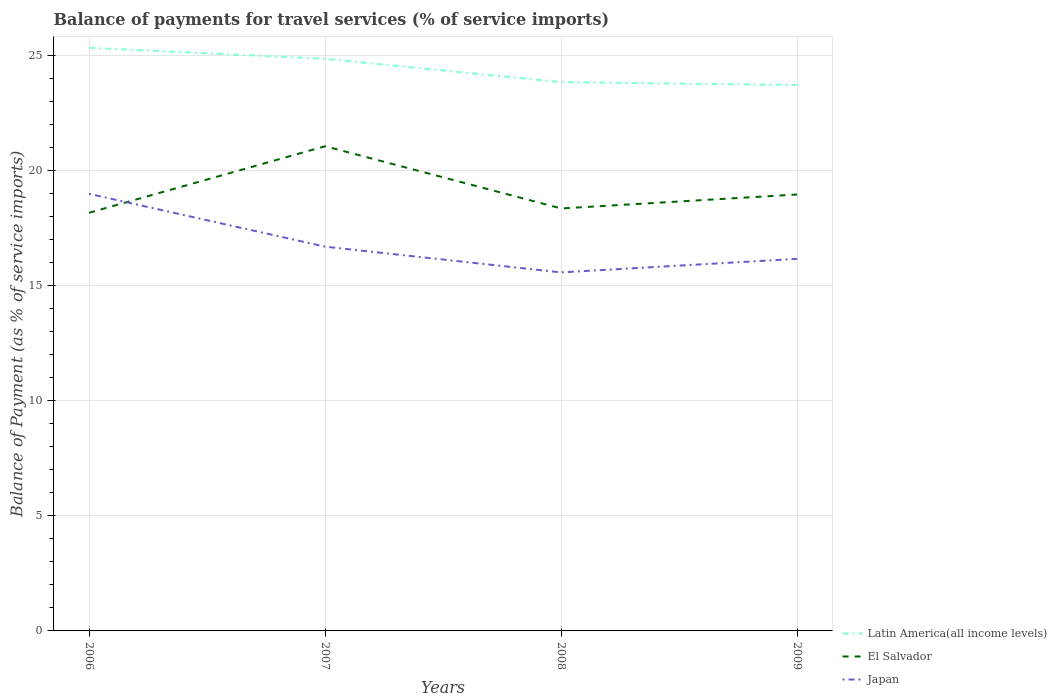How many different coloured lines are there?
Provide a short and direct response. 3. Does the line corresponding to El Salvador intersect with the line corresponding to Latin America(all income levels)?
Your answer should be very brief. No. Across all years, what is the maximum balance of payments for travel services in Japan?
Provide a short and direct response. 15.59. What is the total balance of payments for travel services in Japan in the graph?
Offer a terse response. 1.12. What is the difference between the highest and the second highest balance of payments for travel services in Japan?
Your answer should be very brief. 3.42. Is the balance of payments for travel services in Latin America(all income levels) strictly greater than the balance of payments for travel services in El Salvador over the years?
Give a very brief answer. No. How many lines are there?
Provide a short and direct response. 3. How many years are there in the graph?
Provide a short and direct response. 4. Does the graph contain grids?
Your answer should be compact. Yes. How many legend labels are there?
Your answer should be compact. 3. How are the legend labels stacked?
Give a very brief answer. Vertical. What is the title of the graph?
Your answer should be very brief. Balance of payments for travel services (% of service imports). Does "West Bank and Gaza" appear as one of the legend labels in the graph?
Offer a very short reply. No. What is the label or title of the X-axis?
Offer a very short reply. Years. What is the label or title of the Y-axis?
Offer a very short reply. Balance of Payment (as % of service imports). What is the Balance of Payment (as % of service imports) in Latin America(all income levels) in 2006?
Offer a very short reply. 25.36. What is the Balance of Payment (as % of service imports) in El Salvador in 2006?
Offer a terse response. 18.18. What is the Balance of Payment (as % of service imports) in Japan in 2006?
Your answer should be compact. 19.01. What is the Balance of Payment (as % of service imports) of Latin America(all income levels) in 2007?
Your answer should be very brief. 24.88. What is the Balance of Payment (as % of service imports) of El Salvador in 2007?
Offer a very short reply. 21.08. What is the Balance of Payment (as % of service imports) in Japan in 2007?
Your answer should be very brief. 16.71. What is the Balance of Payment (as % of service imports) in Latin America(all income levels) in 2008?
Offer a terse response. 23.86. What is the Balance of Payment (as % of service imports) of El Salvador in 2008?
Your answer should be compact. 18.37. What is the Balance of Payment (as % of service imports) in Japan in 2008?
Give a very brief answer. 15.59. What is the Balance of Payment (as % of service imports) of Latin America(all income levels) in 2009?
Give a very brief answer. 23.74. What is the Balance of Payment (as % of service imports) of El Salvador in 2009?
Keep it short and to the point. 18.98. What is the Balance of Payment (as % of service imports) of Japan in 2009?
Your response must be concise. 16.18. Across all years, what is the maximum Balance of Payment (as % of service imports) of Latin America(all income levels)?
Offer a terse response. 25.36. Across all years, what is the maximum Balance of Payment (as % of service imports) of El Salvador?
Your answer should be very brief. 21.08. Across all years, what is the maximum Balance of Payment (as % of service imports) in Japan?
Offer a very short reply. 19.01. Across all years, what is the minimum Balance of Payment (as % of service imports) in Latin America(all income levels)?
Your answer should be very brief. 23.74. Across all years, what is the minimum Balance of Payment (as % of service imports) in El Salvador?
Your answer should be very brief. 18.18. Across all years, what is the minimum Balance of Payment (as % of service imports) of Japan?
Give a very brief answer. 15.59. What is the total Balance of Payment (as % of service imports) in Latin America(all income levels) in the graph?
Ensure brevity in your answer.  97.83. What is the total Balance of Payment (as % of service imports) of El Salvador in the graph?
Offer a very short reply. 76.61. What is the total Balance of Payment (as % of service imports) in Japan in the graph?
Give a very brief answer. 67.48. What is the difference between the Balance of Payment (as % of service imports) of Latin America(all income levels) in 2006 and that in 2007?
Offer a very short reply. 0.48. What is the difference between the Balance of Payment (as % of service imports) in El Salvador in 2006 and that in 2007?
Your answer should be compact. -2.89. What is the difference between the Balance of Payment (as % of service imports) of Japan in 2006 and that in 2007?
Make the answer very short. 2.3. What is the difference between the Balance of Payment (as % of service imports) in Latin America(all income levels) in 2006 and that in 2008?
Ensure brevity in your answer.  1.49. What is the difference between the Balance of Payment (as % of service imports) in El Salvador in 2006 and that in 2008?
Your answer should be compact. -0.19. What is the difference between the Balance of Payment (as % of service imports) in Japan in 2006 and that in 2008?
Provide a short and direct response. 3.42. What is the difference between the Balance of Payment (as % of service imports) in Latin America(all income levels) in 2006 and that in 2009?
Give a very brief answer. 1.62. What is the difference between the Balance of Payment (as % of service imports) of El Salvador in 2006 and that in 2009?
Provide a short and direct response. -0.79. What is the difference between the Balance of Payment (as % of service imports) in Japan in 2006 and that in 2009?
Make the answer very short. 2.83. What is the difference between the Balance of Payment (as % of service imports) in Latin America(all income levels) in 2007 and that in 2008?
Your answer should be very brief. 1.02. What is the difference between the Balance of Payment (as % of service imports) in El Salvador in 2007 and that in 2008?
Keep it short and to the point. 2.71. What is the difference between the Balance of Payment (as % of service imports) of Japan in 2007 and that in 2008?
Your response must be concise. 1.12. What is the difference between the Balance of Payment (as % of service imports) in Latin America(all income levels) in 2007 and that in 2009?
Your response must be concise. 1.14. What is the difference between the Balance of Payment (as % of service imports) in El Salvador in 2007 and that in 2009?
Offer a very short reply. 2.1. What is the difference between the Balance of Payment (as % of service imports) of Japan in 2007 and that in 2009?
Give a very brief answer. 0.53. What is the difference between the Balance of Payment (as % of service imports) in Latin America(all income levels) in 2008 and that in 2009?
Your answer should be compact. 0.13. What is the difference between the Balance of Payment (as % of service imports) in El Salvador in 2008 and that in 2009?
Make the answer very short. -0.61. What is the difference between the Balance of Payment (as % of service imports) of Japan in 2008 and that in 2009?
Your answer should be compact. -0.59. What is the difference between the Balance of Payment (as % of service imports) in Latin America(all income levels) in 2006 and the Balance of Payment (as % of service imports) in El Salvador in 2007?
Offer a terse response. 4.28. What is the difference between the Balance of Payment (as % of service imports) in Latin America(all income levels) in 2006 and the Balance of Payment (as % of service imports) in Japan in 2007?
Offer a very short reply. 8.65. What is the difference between the Balance of Payment (as % of service imports) in El Salvador in 2006 and the Balance of Payment (as % of service imports) in Japan in 2007?
Provide a succinct answer. 1.48. What is the difference between the Balance of Payment (as % of service imports) in Latin America(all income levels) in 2006 and the Balance of Payment (as % of service imports) in El Salvador in 2008?
Provide a short and direct response. 6.99. What is the difference between the Balance of Payment (as % of service imports) of Latin America(all income levels) in 2006 and the Balance of Payment (as % of service imports) of Japan in 2008?
Offer a very short reply. 9.77. What is the difference between the Balance of Payment (as % of service imports) in El Salvador in 2006 and the Balance of Payment (as % of service imports) in Japan in 2008?
Your answer should be very brief. 2.59. What is the difference between the Balance of Payment (as % of service imports) of Latin America(all income levels) in 2006 and the Balance of Payment (as % of service imports) of El Salvador in 2009?
Your response must be concise. 6.38. What is the difference between the Balance of Payment (as % of service imports) of Latin America(all income levels) in 2006 and the Balance of Payment (as % of service imports) of Japan in 2009?
Make the answer very short. 9.18. What is the difference between the Balance of Payment (as % of service imports) in El Salvador in 2006 and the Balance of Payment (as % of service imports) in Japan in 2009?
Offer a terse response. 2. What is the difference between the Balance of Payment (as % of service imports) of Latin America(all income levels) in 2007 and the Balance of Payment (as % of service imports) of El Salvador in 2008?
Offer a terse response. 6.51. What is the difference between the Balance of Payment (as % of service imports) of Latin America(all income levels) in 2007 and the Balance of Payment (as % of service imports) of Japan in 2008?
Your answer should be very brief. 9.29. What is the difference between the Balance of Payment (as % of service imports) of El Salvador in 2007 and the Balance of Payment (as % of service imports) of Japan in 2008?
Provide a short and direct response. 5.49. What is the difference between the Balance of Payment (as % of service imports) of Latin America(all income levels) in 2007 and the Balance of Payment (as % of service imports) of El Salvador in 2009?
Your answer should be very brief. 5.9. What is the difference between the Balance of Payment (as % of service imports) in Latin America(all income levels) in 2007 and the Balance of Payment (as % of service imports) in Japan in 2009?
Give a very brief answer. 8.7. What is the difference between the Balance of Payment (as % of service imports) of El Salvador in 2007 and the Balance of Payment (as % of service imports) of Japan in 2009?
Your response must be concise. 4.9. What is the difference between the Balance of Payment (as % of service imports) in Latin America(all income levels) in 2008 and the Balance of Payment (as % of service imports) in El Salvador in 2009?
Your answer should be very brief. 4.88. What is the difference between the Balance of Payment (as % of service imports) in Latin America(all income levels) in 2008 and the Balance of Payment (as % of service imports) in Japan in 2009?
Offer a terse response. 7.68. What is the difference between the Balance of Payment (as % of service imports) of El Salvador in 2008 and the Balance of Payment (as % of service imports) of Japan in 2009?
Provide a short and direct response. 2.19. What is the average Balance of Payment (as % of service imports) of Latin America(all income levels) per year?
Make the answer very short. 24.46. What is the average Balance of Payment (as % of service imports) in El Salvador per year?
Provide a short and direct response. 19.15. What is the average Balance of Payment (as % of service imports) in Japan per year?
Your answer should be compact. 16.87. In the year 2006, what is the difference between the Balance of Payment (as % of service imports) in Latin America(all income levels) and Balance of Payment (as % of service imports) in El Salvador?
Offer a terse response. 7.17. In the year 2006, what is the difference between the Balance of Payment (as % of service imports) of Latin America(all income levels) and Balance of Payment (as % of service imports) of Japan?
Provide a succinct answer. 6.35. In the year 2006, what is the difference between the Balance of Payment (as % of service imports) in El Salvador and Balance of Payment (as % of service imports) in Japan?
Keep it short and to the point. -0.82. In the year 2007, what is the difference between the Balance of Payment (as % of service imports) of Latin America(all income levels) and Balance of Payment (as % of service imports) of El Salvador?
Your answer should be compact. 3.8. In the year 2007, what is the difference between the Balance of Payment (as % of service imports) of Latin America(all income levels) and Balance of Payment (as % of service imports) of Japan?
Give a very brief answer. 8.17. In the year 2007, what is the difference between the Balance of Payment (as % of service imports) of El Salvador and Balance of Payment (as % of service imports) of Japan?
Make the answer very short. 4.37. In the year 2008, what is the difference between the Balance of Payment (as % of service imports) in Latin America(all income levels) and Balance of Payment (as % of service imports) in El Salvador?
Offer a very short reply. 5.49. In the year 2008, what is the difference between the Balance of Payment (as % of service imports) of Latin America(all income levels) and Balance of Payment (as % of service imports) of Japan?
Offer a terse response. 8.27. In the year 2008, what is the difference between the Balance of Payment (as % of service imports) in El Salvador and Balance of Payment (as % of service imports) in Japan?
Your response must be concise. 2.78. In the year 2009, what is the difference between the Balance of Payment (as % of service imports) of Latin America(all income levels) and Balance of Payment (as % of service imports) of El Salvador?
Your answer should be very brief. 4.76. In the year 2009, what is the difference between the Balance of Payment (as % of service imports) in Latin America(all income levels) and Balance of Payment (as % of service imports) in Japan?
Ensure brevity in your answer.  7.56. In the year 2009, what is the difference between the Balance of Payment (as % of service imports) of El Salvador and Balance of Payment (as % of service imports) of Japan?
Provide a short and direct response. 2.8. What is the ratio of the Balance of Payment (as % of service imports) of Latin America(all income levels) in 2006 to that in 2007?
Provide a short and direct response. 1.02. What is the ratio of the Balance of Payment (as % of service imports) of El Salvador in 2006 to that in 2007?
Provide a short and direct response. 0.86. What is the ratio of the Balance of Payment (as % of service imports) of Japan in 2006 to that in 2007?
Give a very brief answer. 1.14. What is the ratio of the Balance of Payment (as % of service imports) of Latin America(all income levels) in 2006 to that in 2008?
Ensure brevity in your answer.  1.06. What is the ratio of the Balance of Payment (as % of service imports) of El Salvador in 2006 to that in 2008?
Your answer should be compact. 0.99. What is the ratio of the Balance of Payment (as % of service imports) in Japan in 2006 to that in 2008?
Give a very brief answer. 1.22. What is the ratio of the Balance of Payment (as % of service imports) of Latin America(all income levels) in 2006 to that in 2009?
Provide a succinct answer. 1.07. What is the ratio of the Balance of Payment (as % of service imports) of El Salvador in 2006 to that in 2009?
Ensure brevity in your answer.  0.96. What is the ratio of the Balance of Payment (as % of service imports) of Japan in 2006 to that in 2009?
Offer a terse response. 1.17. What is the ratio of the Balance of Payment (as % of service imports) of Latin America(all income levels) in 2007 to that in 2008?
Your response must be concise. 1.04. What is the ratio of the Balance of Payment (as % of service imports) in El Salvador in 2007 to that in 2008?
Give a very brief answer. 1.15. What is the ratio of the Balance of Payment (as % of service imports) in Japan in 2007 to that in 2008?
Make the answer very short. 1.07. What is the ratio of the Balance of Payment (as % of service imports) in Latin America(all income levels) in 2007 to that in 2009?
Your response must be concise. 1.05. What is the ratio of the Balance of Payment (as % of service imports) of El Salvador in 2007 to that in 2009?
Ensure brevity in your answer.  1.11. What is the ratio of the Balance of Payment (as % of service imports) of Japan in 2007 to that in 2009?
Your answer should be very brief. 1.03. What is the ratio of the Balance of Payment (as % of service imports) in Latin America(all income levels) in 2008 to that in 2009?
Offer a very short reply. 1.01. What is the ratio of the Balance of Payment (as % of service imports) of Japan in 2008 to that in 2009?
Keep it short and to the point. 0.96. What is the difference between the highest and the second highest Balance of Payment (as % of service imports) of Latin America(all income levels)?
Ensure brevity in your answer.  0.48. What is the difference between the highest and the second highest Balance of Payment (as % of service imports) in El Salvador?
Provide a short and direct response. 2.1. What is the difference between the highest and the second highest Balance of Payment (as % of service imports) of Japan?
Keep it short and to the point. 2.3. What is the difference between the highest and the lowest Balance of Payment (as % of service imports) in Latin America(all income levels)?
Provide a short and direct response. 1.62. What is the difference between the highest and the lowest Balance of Payment (as % of service imports) of El Salvador?
Offer a very short reply. 2.89. What is the difference between the highest and the lowest Balance of Payment (as % of service imports) in Japan?
Offer a very short reply. 3.42. 